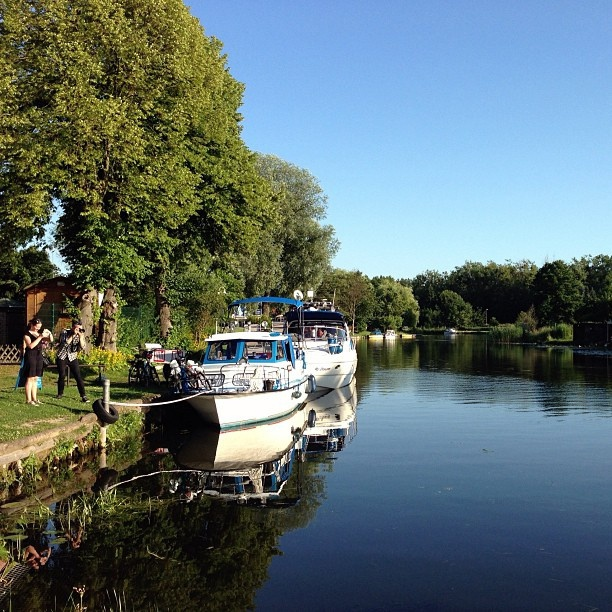Describe the objects in this image and their specific colors. I can see boat in olive, white, black, darkgray, and gray tones, boat in olive, white, black, darkgray, and gray tones, people in olive, black, gray, and darkgreen tones, people in olive, black, lightyellow, tan, and maroon tones, and people in olive, black, gray, and white tones in this image. 